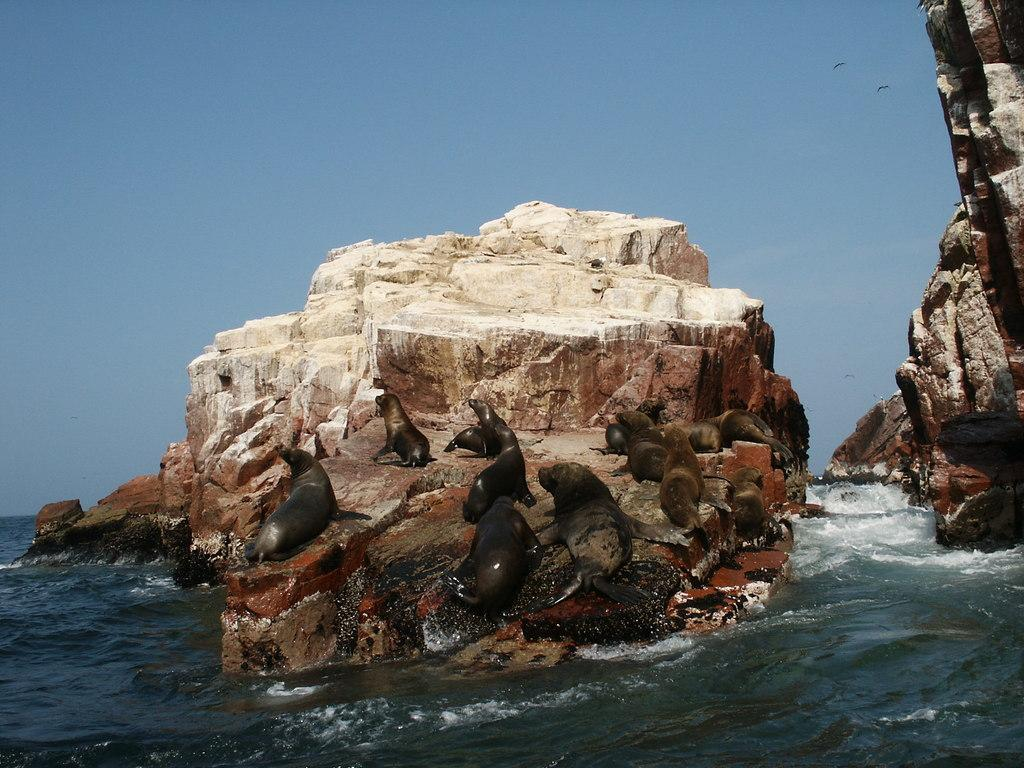What is the main object in the image? There is a rock in the image. What is on top of the rock? There are animals on the rock. What can be seen at the top of the image? The sky is visible at the top of the image. What is at the bottom of the image? There is a lake at the bottom of the image. Where are the scissors located in the image? There are no scissors present in the image. What type of arch can be seen in the image? There is no arch present in the image. 